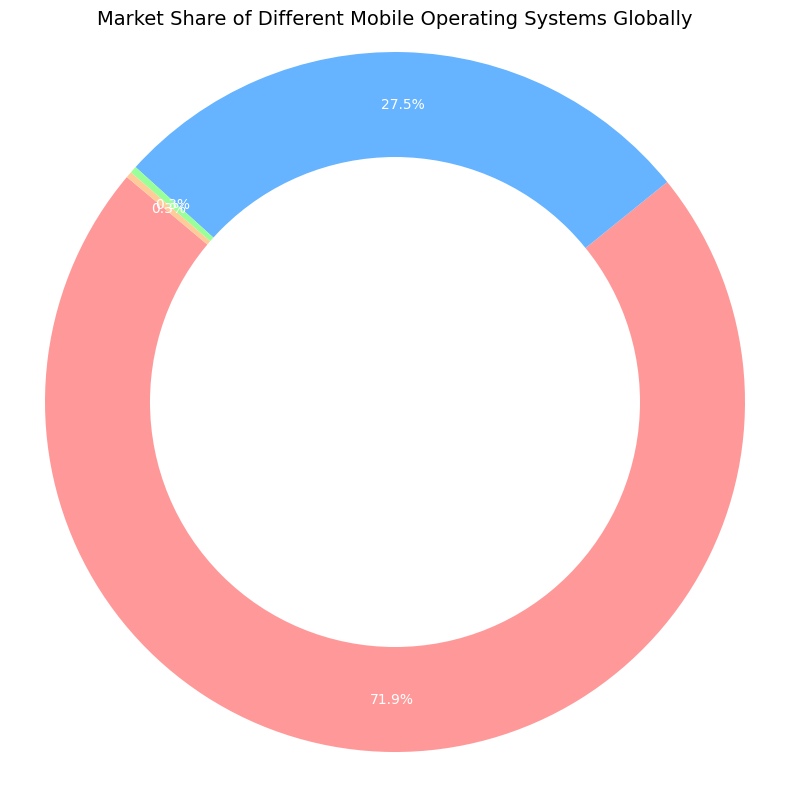What's the market share difference between Android and iOS? Android has a market share of 71.93% and iOS has a market share of 27.47%. Subtracting the market share of iOS from that of Android (71.93% - 27.47%) gives us 44.46%.
Answer: 44.46% What is the sum of the market shares of Windows and Others? Windows has a market share of 0.32% and Others has a market share of 0.28%. Adding these two values (0.32% + 0.28%) gives us 0.60%.
Answer: 0.60% Which operating system has the lowest market share? By looking at the market share values, Others has the lowest market share at 0.28%.
Answer: Others Is the market share of Android greater than the combined market share of iOS, Windows, and Others? Adding the market shares of iOS (27.47%), Windows (0.32%), and Others (0.28%) gives 28.07%. Android has a market share of 71.93%, which is indeed greater than 28.07%.
Answer: Yes What percentage of the market do iOS and Windows collectively hold? The market share of iOS is 27.47% and Windows is 0.32%. Adding these together (27.47% + 0.32%) gives 27.79%.
Answer: 27.79% What is the color representing iOS in the chart? In the chart, iOS is represented by the blue color.
Answer: Blue Between Windows and Others, which has a larger market share, and by how much? Windows has a market share of 0.32% and Others has 0.28%. Subtracting the market share of Others from that of Windows (0.32% - 0.28%) gives 0.04%, indicating Windows has a larger market share by 0.04%.
Answer: Windows, 0.04% If we combine the market shares of all non-Android operating systems, what portion of the market do they represent? iOS has 27.47%, Windows has 0.32%, and Others have 0.28%. Adding these together (27.47% + 0.32% + 0.28%) gives 28.07%.
Answer: 28.07% What is the color representing Android in the chart? In the chart, Android is represented by the red color.
Answer: Red 